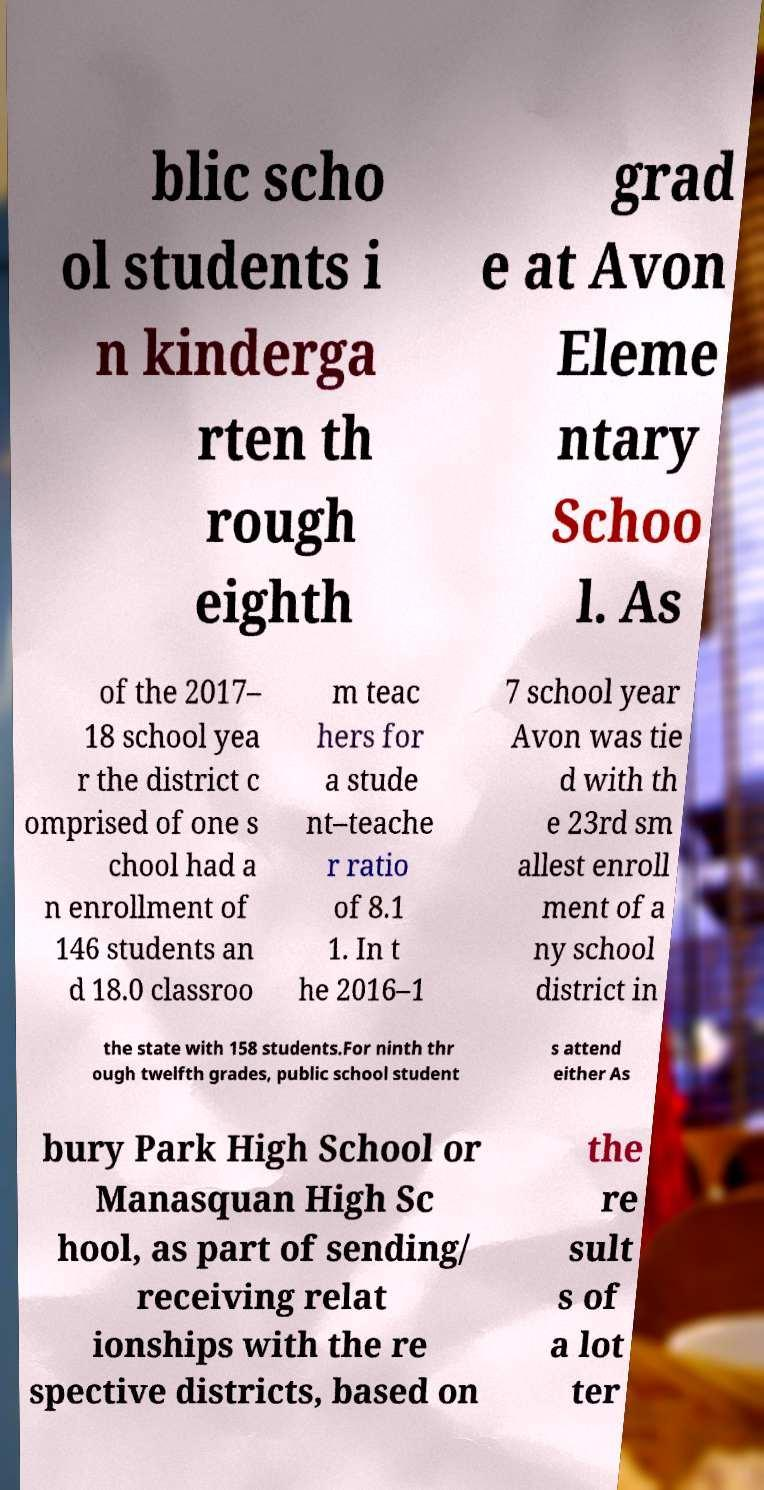Could you extract and type out the text from this image? blic scho ol students i n kinderga rten th rough eighth grad e at Avon Eleme ntary Schoo l. As of the 2017– 18 school yea r the district c omprised of one s chool had a n enrollment of 146 students an d 18.0 classroo m teac hers for a stude nt–teache r ratio of 8.1 1. In t he 2016–1 7 school year Avon was tie d with th e 23rd sm allest enroll ment of a ny school district in the state with 158 students.For ninth thr ough twelfth grades, public school student s attend either As bury Park High School or Manasquan High Sc hool, as part of sending/ receiving relat ionships with the re spective districts, based on the re sult s of a lot ter 